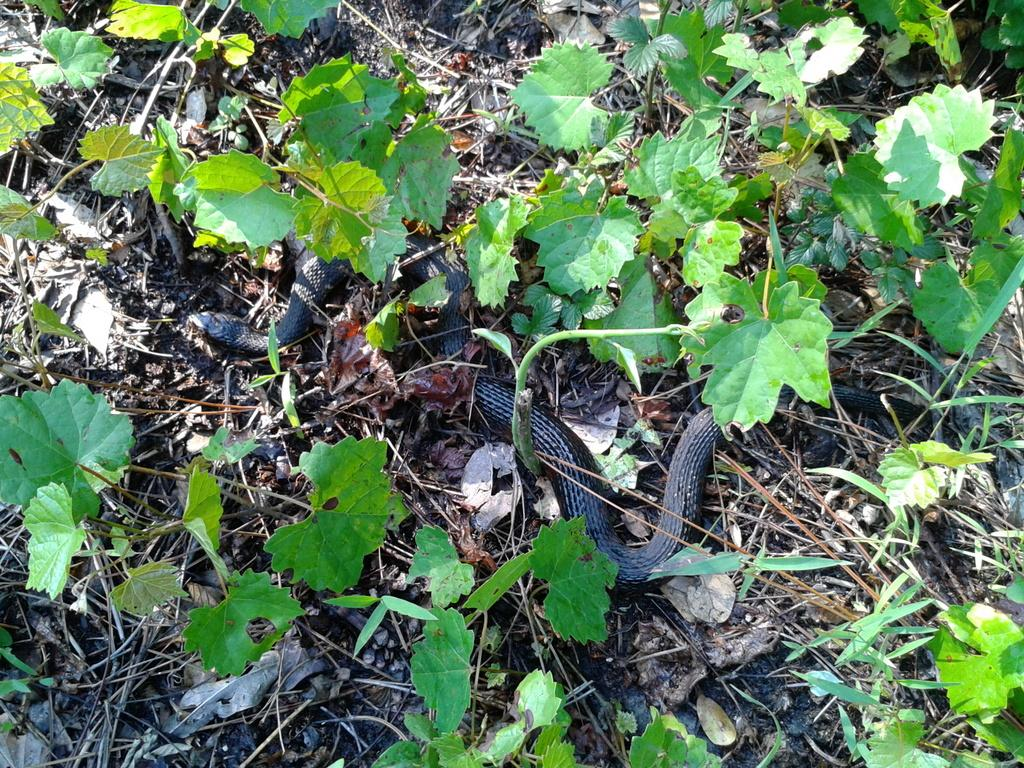What animal can be seen on the ground in the image? There is a snake on the ground in the image. What type of vegetation is visible in the image? There are leaves visible in the image. What else can be seen on the ground in the image? There are sticks visible in the image. Where is the harbor located in the image? There is no harbor present in the image. What type of knot is the snake using to hold onto the sticks? The snake does not use a knot to hold onto the sticks; it is a living creature and not capable of tying knots. 